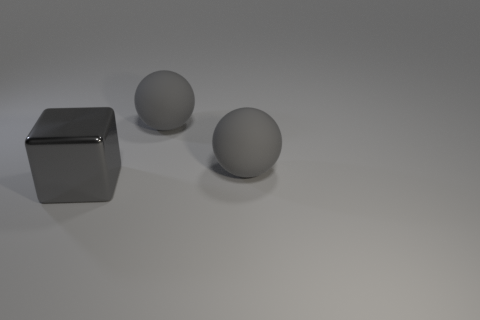Is there anything else that has the same material as the gray cube?
Provide a succinct answer. No. Is there any other thing of the same color as the cube?
Your answer should be compact. Yes. Is there a purple ball?
Provide a succinct answer. No. How many other shiny objects have the same size as the metallic thing?
Your answer should be very brief. 0. Are there any large metallic blocks of the same color as the metal object?
Give a very brief answer. No. How many other objects are there of the same material as the large gray cube?
Make the answer very short. 0. What is the shape of the metallic object?
Offer a very short reply. Cube. Is the number of big objects to the right of the metallic cube greater than the number of tiny balls?
Ensure brevity in your answer.  Yes. Is there any other thing that has the same shape as the big shiny thing?
Your response must be concise. No. There is a big metal thing; are there any large gray objects on the left side of it?
Make the answer very short. No. 